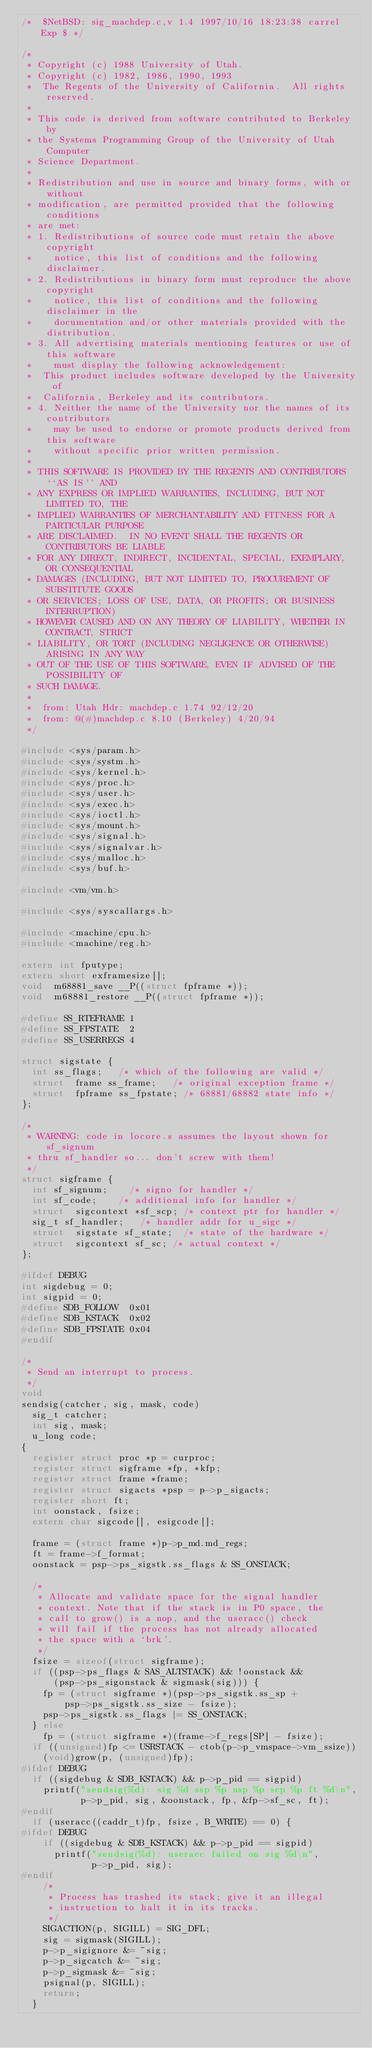Convert code to text. <code><loc_0><loc_0><loc_500><loc_500><_C_>/*	$NetBSD: sig_machdep.c,v 1.4 1997/10/16 18:23:38 carrel Exp $	*/

/*
 * Copyright (c) 1988 University of Utah.
 * Copyright (c) 1982, 1986, 1990, 1993
 *	The Regents of the University of California.  All rights reserved.
 *
 * This code is derived from software contributed to Berkeley by
 * the Systems Programming Group of the University of Utah Computer
 * Science Department.
 *
 * Redistribution and use in source and binary forms, with or without
 * modification, are permitted provided that the following conditions
 * are met:
 * 1. Redistributions of source code must retain the above copyright
 *    notice, this list of conditions and the following disclaimer.
 * 2. Redistributions in binary form must reproduce the above copyright
 *    notice, this list of conditions and the following disclaimer in the
 *    documentation and/or other materials provided with the distribution.
 * 3. All advertising materials mentioning features or use of this software
 *    must display the following acknowledgement:
 *	This product includes software developed by the University of
 *	California, Berkeley and its contributors.
 * 4. Neither the name of the University nor the names of its contributors
 *    may be used to endorse or promote products derived from this software
 *    without specific prior written permission.
 *
 * THIS SOFTWARE IS PROVIDED BY THE REGENTS AND CONTRIBUTORS ``AS IS'' AND
 * ANY EXPRESS OR IMPLIED WARRANTIES, INCLUDING, BUT NOT LIMITED TO, THE
 * IMPLIED WARRANTIES OF MERCHANTABILITY AND FITNESS FOR A PARTICULAR PURPOSE
 * ARE DISCLAIMED.  IN NO EVENT SHALL THE REGENTS OR CONTRIBUTORS BE LIABLE
 * FOR ANY DIRECT, INDIRECT, INCIDENTAL, SPECIAL, EXEMPLARY, OR CONSEQUENTIAL
 * DAMAGES (INCLUDING, BUT NOT LIMITED TO, PROCUREMENT OF SUBSTITUTE GOODS
 * OR SERVICES; LOSS OF USE, DATA, OR PROFITS; OR BUSINESS INTERRUPTION)
 * HOWEVER CAUSED AND ON ANY THEORY OF LIABILITY, WHETHER IN CONTRACT, STRICT
 * LIABILITY, OR TORT (INCLUDING NEGLIGENCE OR OTHERWISE) ARISING IN ANY WAY
 * OUT OF THE USE OF THIS SOFTWARE, EVEN IF ADVISED OF THE POSSIBILITY OF
 * SUCH DAMAGE.
 *
 *	from: Utah Hdr: machdep.c 1.74 92/12/20
 *	from: @(#)machdep.c	8.10 (Berkeley) 4/20/94
 */

#include <sys/param.h>
#include <sys/systm.h>
#include <sys/kernel.h>
#include <sys/proc.h>
#include <sys/user.h>
#include <sys/exec.h>
#include <sys/ioctl.h>
#include <sys/mount.h>
#include <sys/signal.h>
#include <sys/signalvar.h>
#include <sys/malloc.h>
#include <sys/buf.h>

#include <vm/vm.h>

#include <sys/syscallargs.h>

#include <machine/cpu.h>
#include <machine/reg.h>

extern int fputype;
extern short exframesize[];
void	m68881_save __P((struct fpframe *));
void	m68881_restore __P((struct fpframe *));

#define SS_RTEFRAME	1
#define SS_FPSTATE	2
#define SS_USERREGS	4

struct sigstate {
	int	ss_flags;		/* which of the following are valid */
	struct	frame ss_frame;		/* original exception frame */
	struct	fpframe ss_fpstate;	/* 68881/68882 state info */
};

/*
 * WARNING: code in locore.s assumes the layout shown for sf_signum
 * thru sf_handler so... don't screw with them!
 */
struct sigframe {
	int	sf_signum;		/* signo for handler */
	int	sf_code;		/* additional info for handler */
	struct	sigcontext *sf_scp;	/* context ptr for handler */
	sig_t	sf_handler;		/* handler addr for u_sigc */
	struct	sigstate sf_state;	/* state of the hardware */
	struct	sigcontext sf_sc;	/* actual context */
};

#ifdef DEBUG
int sigdebug = 0;
int sigpid = 0;
#define SDB_FOLLOW	0x01
#define SDB_KSTACK	0x02
#define SDB_FPSTATE	0x04
#endif

/*
 * Send an interrupt to process.
 */
void
sendsig(catcher, sig, mask, code)
	sig_t catcher;
	int sig, mask;
	u_long code;
{
	register struct proc *p = curproc;
	register struct sigframe *fp, *kfp;
	register struct frame *frame;
	register struct sigacts *psp = p->p_sigacts;
	register short ft;
	int oonstack, fsize;
	extern char sigcode[], esigcode[];

	frame = (struct frame *)p->p_md.md_regs;
	ft = frame->f_format;
	oonstack = psp->ps_sigstk.ss_flags & SS_ONSTACK;

	/*
	 * Allocate and validate space for the signal handler
	 * context. Note that if the stack is in P0 space, the
	 * call to grow() is a nop, and the useracc() check
	 * will fail if the process has not already allocated
	 * the space with a `brk'.
	 */
	fsize = sizeof(struct sigframe);
	if ((psp->ps_flags & SAS_ALTSTACK) && !oonstack &&
	    (psp->ps_sigonstack & sigmask(sig))) {
		fp = (struct sigframe *)(psp->ps_sigstk.ss_sp +
		    psp->ps_sigstk.ss_size - fsize);
		psp->ps_sigstk.ss_flags |= SS_ONSTACK;
	} else
		fp = (struct sigframe *)(frame->f_regs[SP] - fsize);
	if ((unsigned)fp <= USRSTACK - ctob(p->p_vmspace->vm_ssize))
		(void)grow(p, (unsigned)fp);
#ifdef DEBUG
	if ((sigdebug & SDB_KSTACK) && p->p_pid == sigpid)
		printf("sendsig(%d): sig %d ssp %p usp %p scp %p ft %d\n",
		       p->p_pid, sig, &oonstack, fp, &fp->sf_sc, ft);
#endif
	if (useracc((caddr_t)fp, fsize, B_WRITE) == 0) {
#ifdef DEBUG
		if ((sigdebug & SDB_KSTACK) && p->p_pid == sigpid)
			printf("sendsig(%d): useracc failed on sig %d\n",
			       p->p_pid, sig);
#endif
		/*
		 * Process has trashed its stack; give it an illegal
		 * instruction to halt it in its tracks.
		 */
		SIGACTION(p, SIGILL) = SIG_DFL;
		sig = sigmask(SIGILL);
		p->p_sigignore &= ~sig;
		p->p_sigcatch &= ~sig;
		p->p_sigmask &= ~sig;
		psignal(p, SIGILL);
		return;
	}</code> 